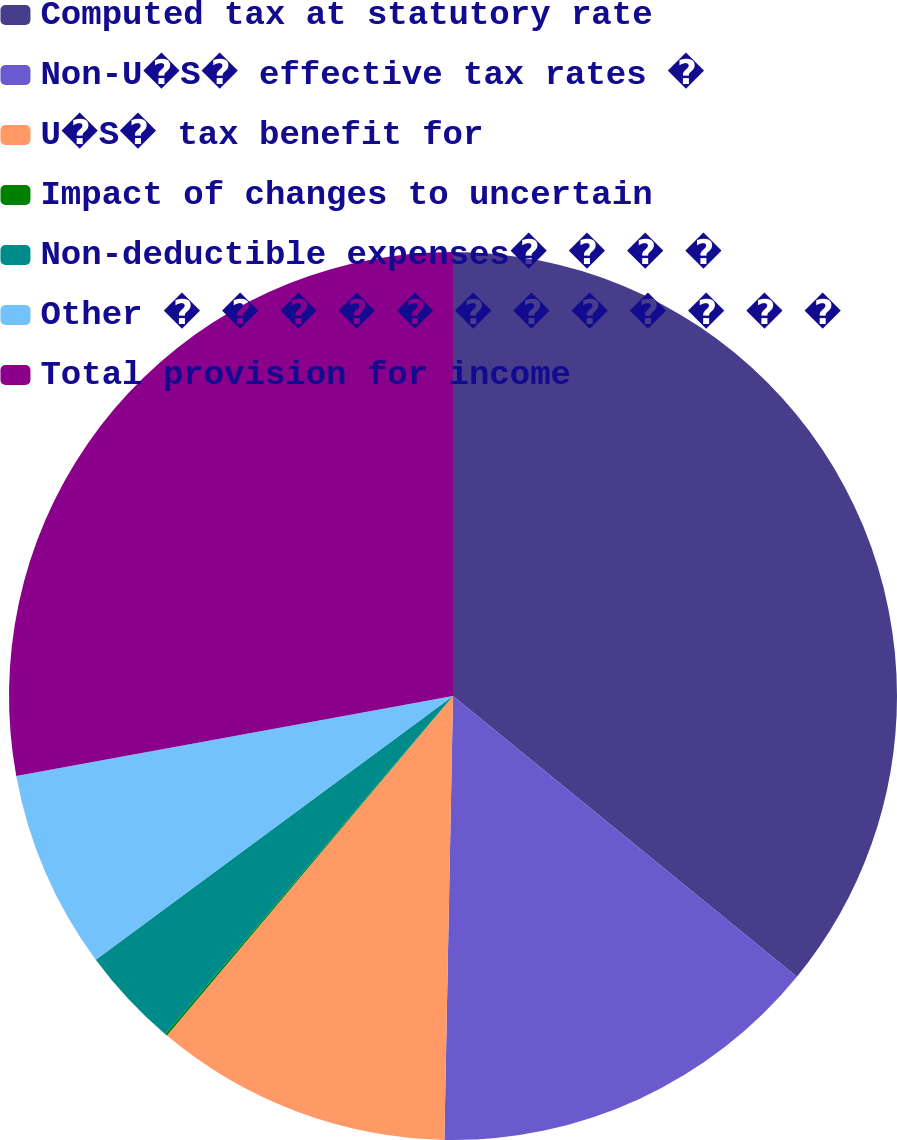<chart> <loc_0><loc_0><loc_500><loc_500><pie_chart><fcel>Computed tax at statutory rate<fcel>Non-U�S� effective tax rates �<fcel>U�S� tax benefit for<fcel>Impact of changes to uncertain<fcel>Non-deductible expenses� � � �<fcel>Other � � � � � � � � � � � �<fcel>Total provision for income<nl><fcel>35.9%<fcel>14.41%<fcel>10.83%<fcel>0.08%<fcel>3.66%<fcel>7.24%<fcel>27.88%<nl></chart> 